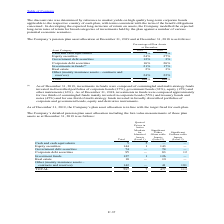According to Stmicroelectronics's financial document, What were the investments composed of as of December 31, 2019? commingled and multi-strategy funds invested in diversified portfolios of corporate bonds (37%), government bonds (32%), equity (15%) and other instruments (16%).. The document states: "er 31, 2019, investments in funds were composed of commingled and multi-strategy funds invested in diversified portfolios of corporate bonds (37%), go..." Also, What was the percentage of investment in corporate bonds as of December 31, 2018? According to the financial document, 55%. The relevant text states: "mingled funds mainly invested in corporate bonds (55%) and treasury bonds and notes (45%) and for one third of multi-strategy funds invested in broadly d..." Also, What was the percentage of investment in treasury bonds and notes in 2018? According to the financial document, 45%. The relevant text states: "rporate bonds (55%) and treasury bonds and notes (45%) and for one third of multi-strategy funds invested in broadly diversified portfolios of corporate..." Also, can you calculate: What was the average investment in cash and cash equivalents? To answer this question, I need to perform calculations using the financial data. The calculation is: (2% + 1%) / 2, which equals 1.5 (percentage). This is based on the information: "Asset Category 2019 2018 Asset Category 2019 2018..." The key data points involved are: 2. Also, can you calculate: What was the increase / (decrease) in the investment in Equity Securities from 2018 to 2019? Based on the calculation: 24% - 27%, the result is -3 (percentage). This is based on the information: "Equity securities 24% 27% Equity securities 24% 27%..." The key data points involved are: 24, 27. Also, can you calculate: What was the increase / (decrease) in the Real estate from 2018 to 2019? Based on the calculation: 2% - 3%, the result is -1 (percentage). This is based on the information: "Government debt securities 12% 3% Government debt securities 12% 3%..." The key data points involved are: 2, 3. 